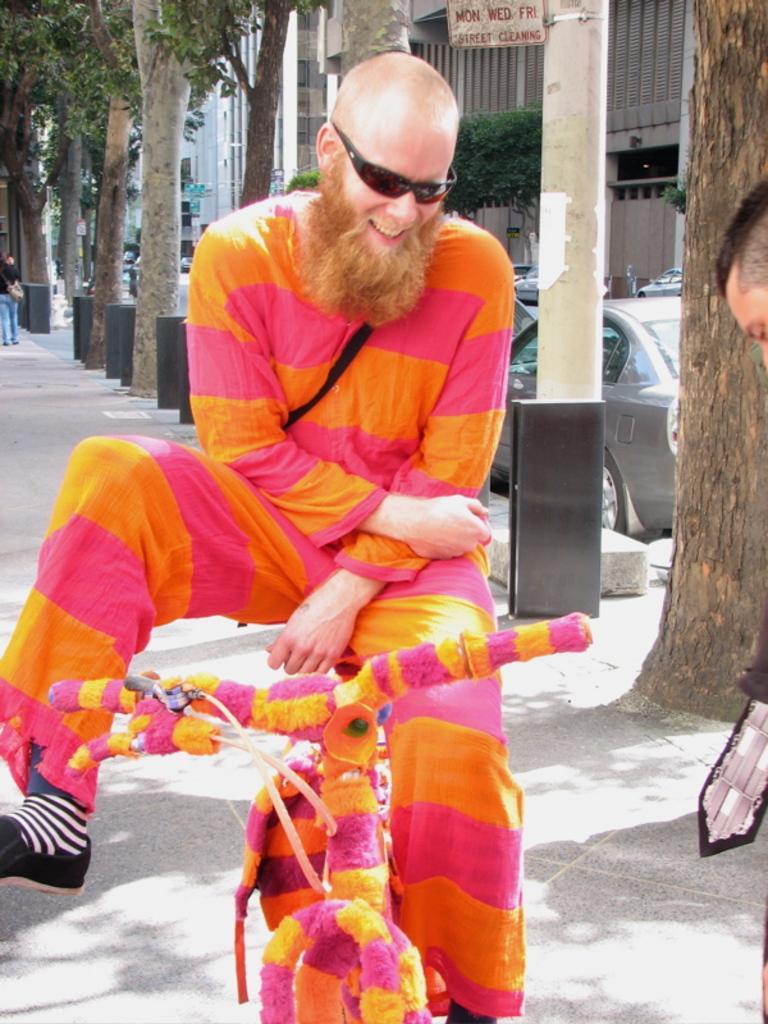In one or two sentences, can you explain what this image depicts? In the picture we can see a man sitting on the bicycle, he is with a different costume and long beard and bald head and beside him we can see a tree and the pole and behind it, we can see a car is parked near the path and we can see some poles and trees behind him. 